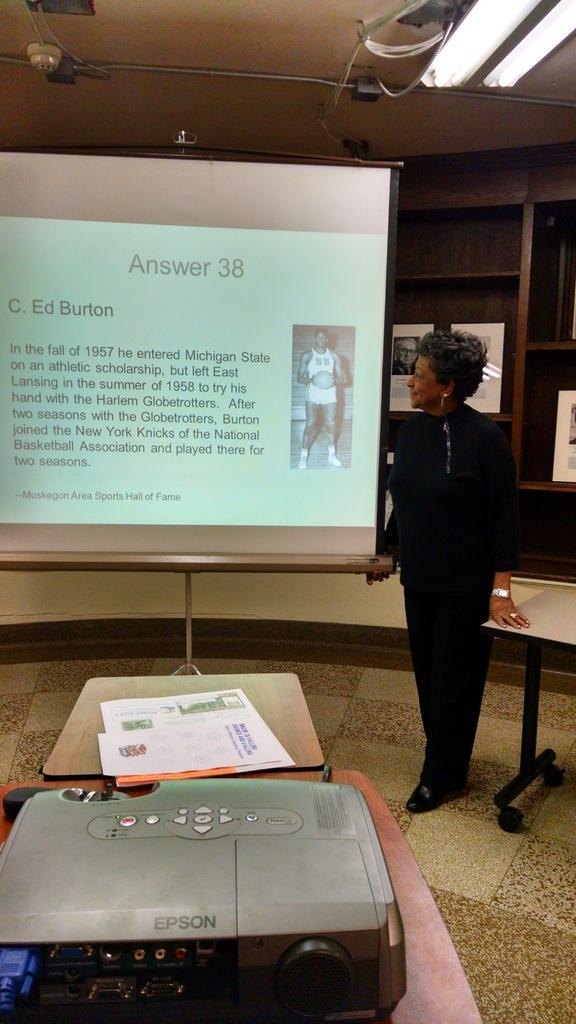Who is present in the image? There is a woman in the image. What is the woman doing in the image? The woman is standing and looking at a projector display. What type of lighting is present in the image? There are electric lights in the image. What device is being used to project the display? There is a projector in the image. What items can be seen on the table in the image? There are papers on a table in the image. What flavor of knot is the woman tying in the image? There is no knot present in the image, and therefore no flavor can be determined. 